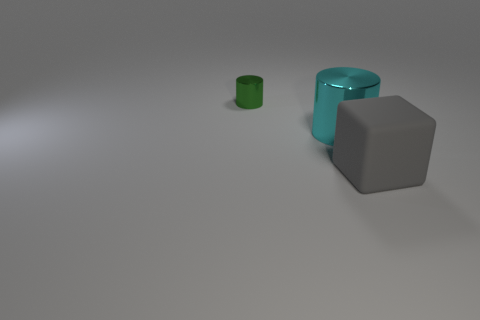Add 1 big matte cubes. How many objects exist? 4 Subtract all cylinders. How many objects are left? 1 Add 2 cyan metallic cylinders. How many cyan metallic cylinders exist? 3 Subtract 0 blue cubes. How many objects are left? 3 Subtract all big gray blocks. Subtract all large red metallic cubes. How many objects are left? 2 Add 1 big gray objects. How many big gray objects are left? 2 